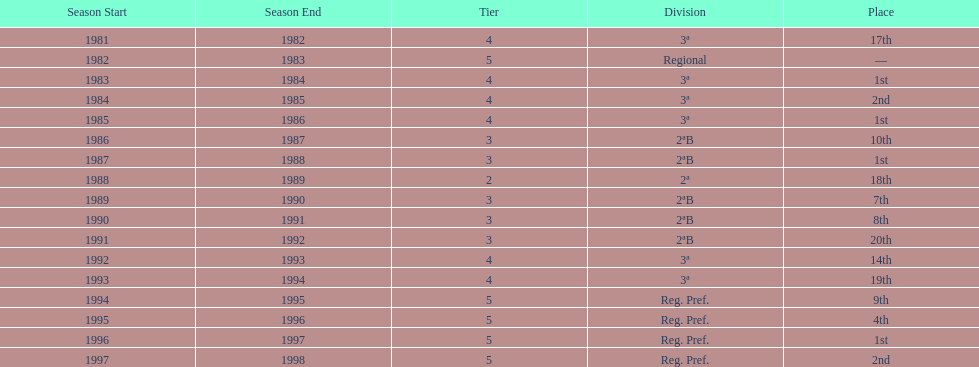Give me the full table as a dictionary. {'header': ['Season Start', 'Season End', 'Tier', 'Division', 'Place'], 'rows': [['1981', '1982', '4', '3ª', '17th'], ['1982', '1983', '5', 'Regional', '—'], ['1983', '1984', '4', '3ª', '1st'], ['1984', '1985', '4', '3ª', '2nd'], ['1985', '1986', '4', '3ª', '1st'], ['1986', '1987', '3', '2ªB', '10th'], ['1987', '1988', '3', '2ªB', '1st'], ['1988', '1989', '2', '2ª', '18th'], ['1989', '1990', '3', '2ªB', '7th'], ['1990', '1991', '3', '2ªB', '8th'], ['1991', '1992', '3', '2ªB', '20th'], ['1992', '1993', '4', '3ª', '14th'], ['1993', '1994', '4', '3ª', '19th'], ['1994', '1995', '5', 'Reg. Pref.', '9th'], ['1995', '1996', '5', 'Reg. Pref.', '4th'], ['1996', '1997', '5', 'Reg. Pref.', '1st'], ['1997', '1998', '5', 'Reg. Pref.', '2nd']]} How many seasons are shown in this chart? 17. 